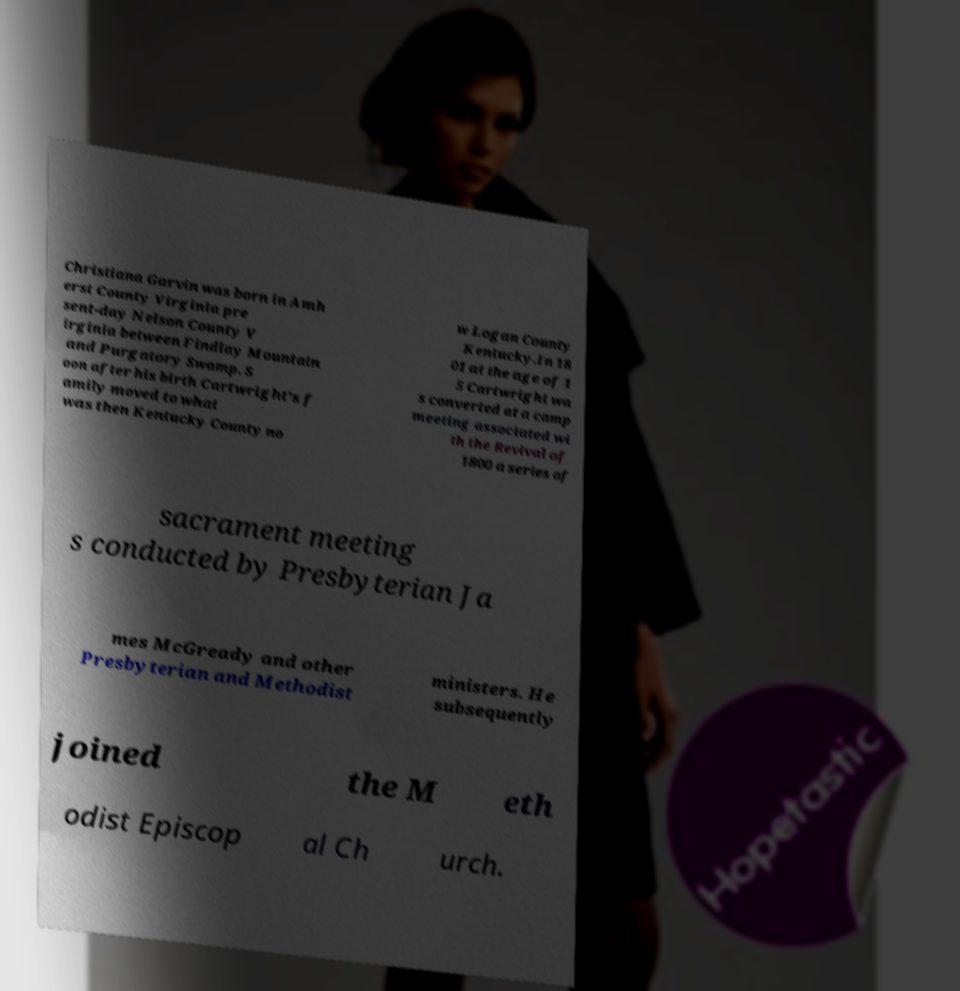Please read and relay the text visible in this image. What does it say? Christiana Garvin was born in Amh erst County Virginia pre sent-day Nelson County V irginia between Findlay Mountain and Purgatory Swamp. S oon after his birth Cartwright's f amily moved to what was then Kentucky County no w Logan County Kentucky.In 18 01 at the age of 1 5 Cartwright wa s converted at a camp meeting associated wi th the Revival of 1800 a series of sacrament meeting s conducted by Presbyterian Ja mes McGready and other Presbyterian and Methodist ministers. He subsequently joined the M eth odist Episcop al Ch urch. 